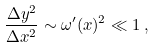Convert formula to latex. <formula><loc_0><loc_0><loc_500><loc_500>\frac { \Delta y ^ { 2 } } { \Delta x ^ { 2 } } \sim \omega ^ { \prime } ( x ) ^ { 2 } \ll 1 \, ,</formula> 